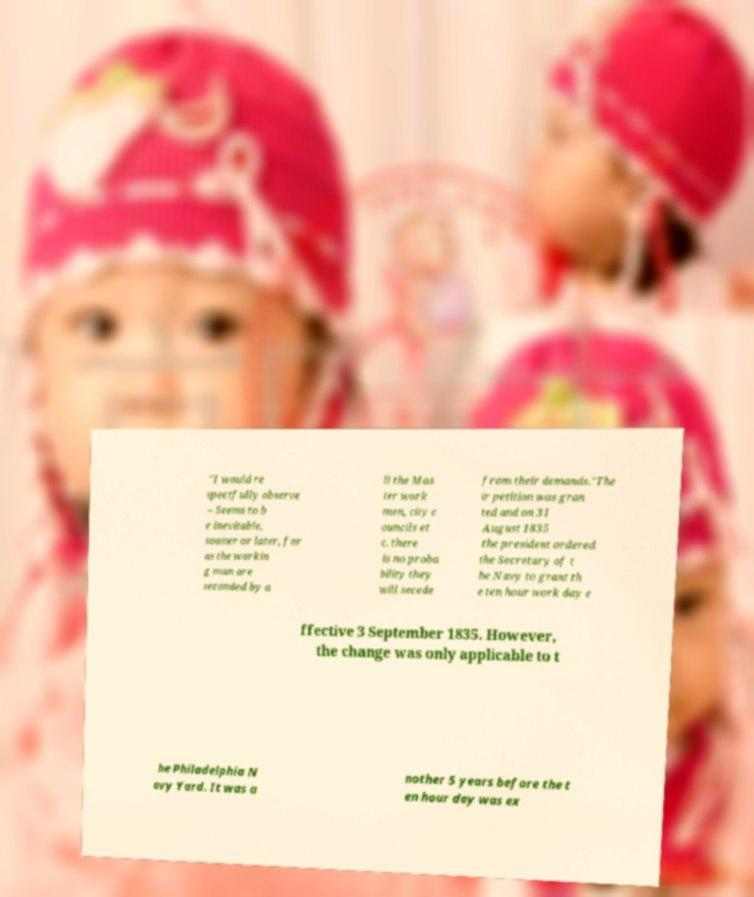There's text embedded in this image that I need extracted. Can you transcribe it verbatim? "I would re spectfully observe – Seems to b e inevitable, sooner or later, for as the workin g man are seconded by a ll the Mas ter work men, city c ouncils et c. there is no proba bility they will secede from their demands."The ir petition was gran ted and on 31 August 1835 the president ordered the Secretary of t he Navy to grant th e ten hour work day e ffective 3 September 1835. However, the change was only applicable to t he Philadelphia N avy Yard. It was a nother 5 years before the t en hour day was ex 